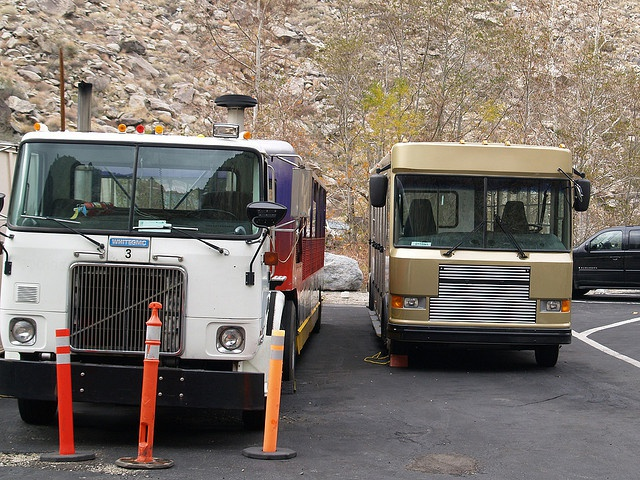Describe the objects in this image and their specific colors. I can see truck in darkgray, black, lightgray, and gray tones, bus in darkgray, black, gray, and white tones, and truck in darkgray, black, gray, and lightgray tones in this image. 